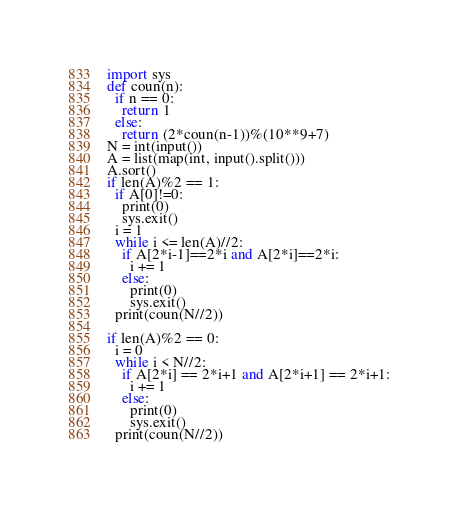<code> <loc_0><loc_0><loc_500><loc_500><_Python_>import sys
def coun(n):
  if n == 0:
    return 1
  else:
    return (2*coun(n-1))%(10**9+7)
N = int(input())
A = list(map(int, input().split()))
A.sort()
if len(A)%2 == 1:
  if A[0]!=0:
    print(0)
    sys.exit()
  i = 1
  while i <= len(A)//2:
    if A[2*i-1]==2*i and A[2*i]==2*i:
      i += 1
    else:
      print(0)
      sys.exit()
  print(coun(N//2))

if len(A)%2 == 0:
  i = 0
  while i < N//2:
    if A[2*i] == 2*i+1 and A[2*i+1] == 2*i+1:
      i += 1
    else:
      print(0)
      sys.exit()
  print(coun(N//2))</code> 